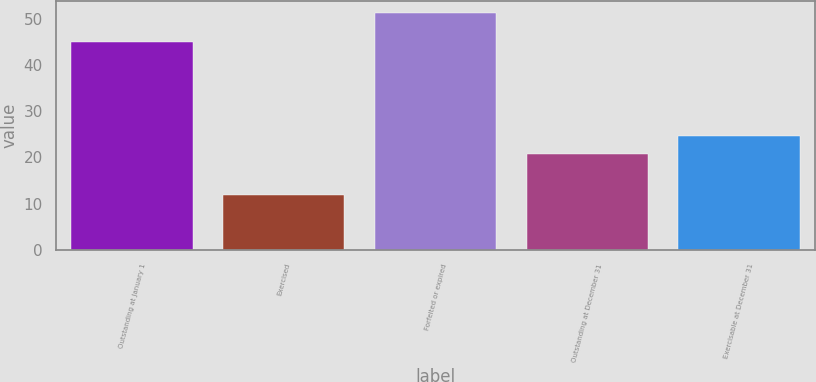<chart> <loc_0><loc_0><loc_500><loc_500><bar_chart><fcel>Outstanding at January 1<fcel>Exercised<fcel>Forfeited or expired<fcel>Outstanding at December 31<fcel>Exercisable at December 31<nl><fcel>45<fcel>11.88<fcel>51.23<fcel>20.72<fcel>24.65<nl></chart> 